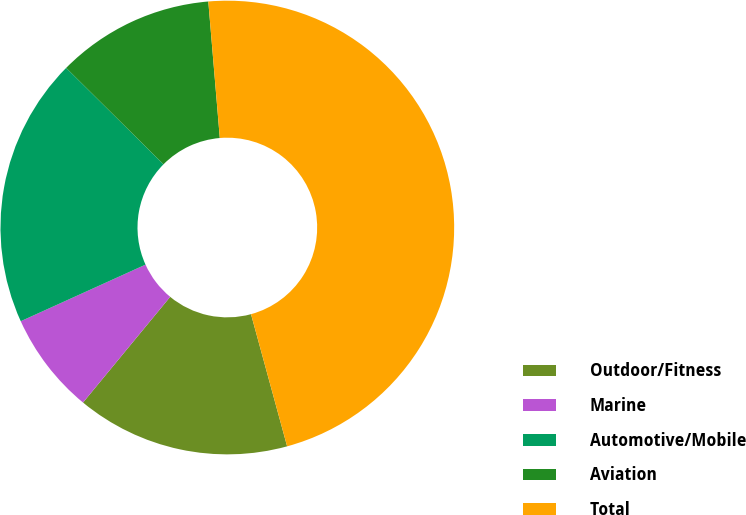Convert chart. <chart><loc_0><loc_0><loc_500><loc_500><pie_chart><fcel>Outdoor/Fitness<fcel>Marine<fcel>Automotive/Mobile<fcel>Aviation<fcel>Total<nl><fcel>15.22%<fcel>7.25%<fcel>19.2%<fcel>11.24%<fcel>47.09%<nl></chart> 